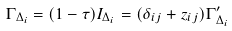<formula> <loc_0><loc_0><loc_500><loc_500>\Gamma _ { \Delta _ { i } } = ( 1 - \tau ) I _ { \Delta _ { i } } = ( \delta _ { i j } + z _ { i j } ) \Gamma ^ { \prime } _ { \Delta _ { i } }</formula> 